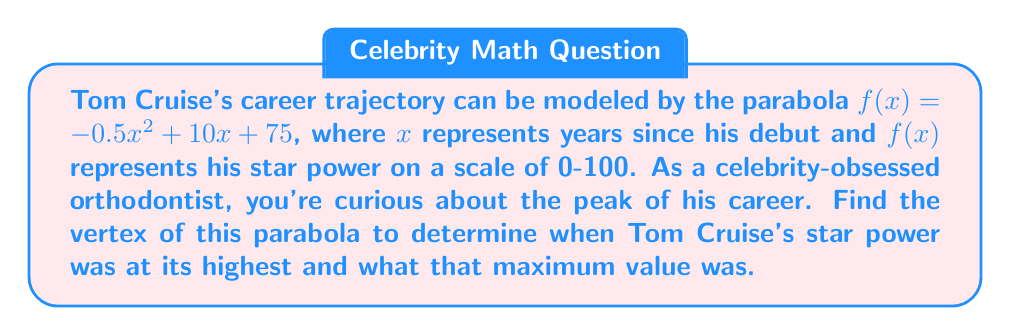Could you help me with this problem? To find the vertex of a parabola in the form $f(x) = ax^2 + bx + c$, we use the formula:

$$x = -\frac{b}{2a}$$

For $f(x) = -0.5x^2 + 10x + 75$, we have $a = -0.5$ and $b = 10$.

1) Calculate x-coordinate of the vertex:
   $$x = -\frac{10}{2(-0.5)} = -\frac{10}{-1} = 10$$

2) To find the y-coordinate, substitute $x = 10$ into the original function:
   $$f(10) = -0.5(10)^2 + 10(10) + 75$$
   $$= -0.5(100) + 100 + 75$$
   $$= -50 + 100 + 75$$
   $$= 125$$

3) Therefore, the vertex is (10, 125).

This means Tom Cruise's star power peaked 10 years after his debut, reaching a maximum value of 125 on the star power scale.
Answer: (10, 125) 